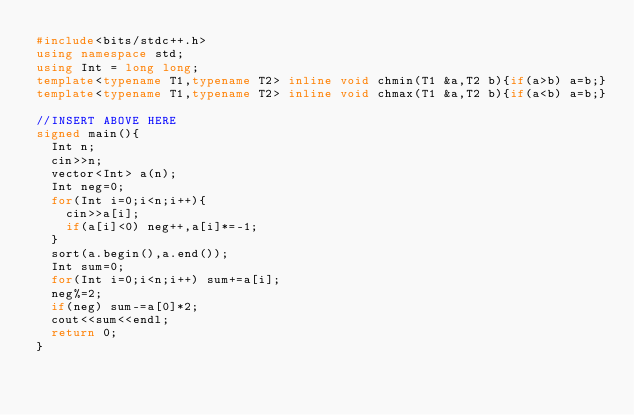<code> <loc_0><loc_0><loc_500><loc_500><_C++_>#include<bits/stdc++.h>
using namespace std;
using Int = long long;
template<typename T1,typename T2> inline void chmin(T1 &a,T2 b){if(a>b) a=b;}
template<typename T1,typename T2> inline void chmax(T1 &a,T2 b){if(a<b) a=b;}

//INSERT ABOVE HERE
signed main(){
  Int n;
  cin>>n;
  vector<Int> a(n);
  Int neg=0;
  for(Int i=0;i<n;i++){
    cin>>a[i];
    if(a[i]<0) neg++,a[i]*=-1;
  }
  sort(a.begin(),a.end());
  Int sum=0;
  for(Int i=0;i<n;i++) sum+=a[i];
  neg%=2;
  if(neg) sum-=a[0]*2;
  cout<<sum<<endl;
  return 0;
}
</code> 